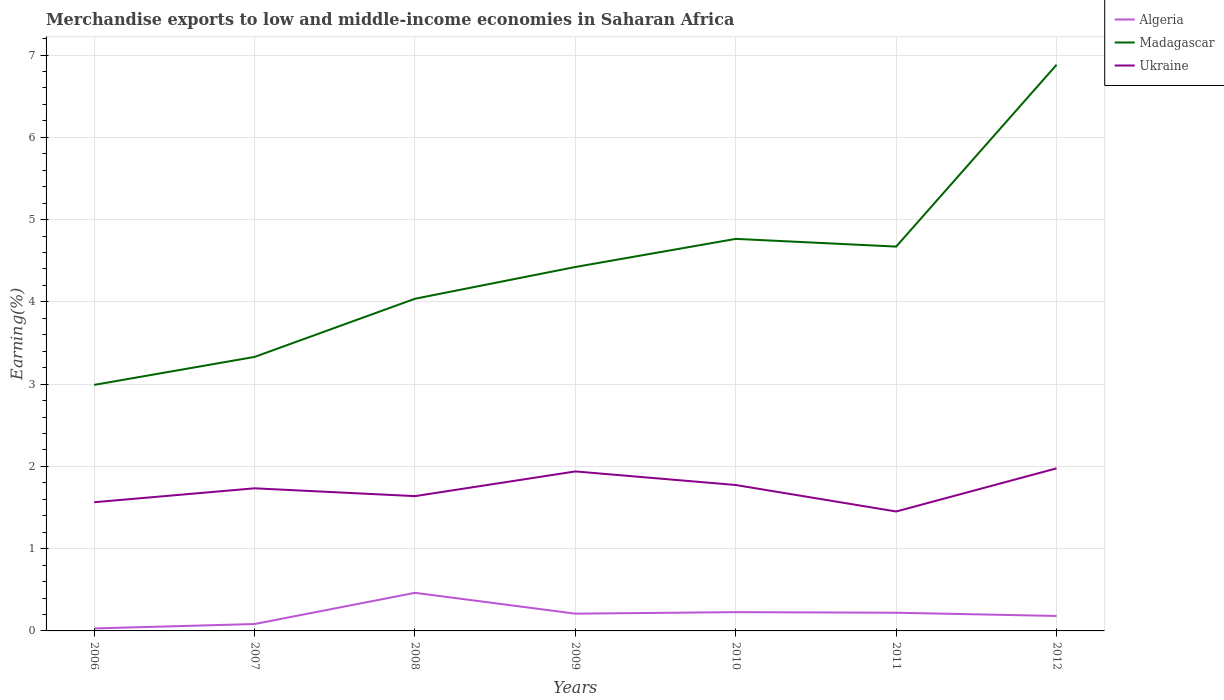Does the line corresponding to Algeria intersect with the line corresponding to Madagascar?
Provide a succinct answer. No. Is the number of lines equal to the number of legend labels?
Make the answer very short. Yes. Across all years, what is the maximum percentage of amount earned from merchandise exports in Madagascar?
Offer a very short reply. 2.99. In which year was the percentage of amount earned from merchandise exports in Madagascar maximum?
Provide a short and direct response. 2006. What is the total percentage of amount earned from merchandise exports in Ukraine in the graph?
Offer a terse response. -0.21. What is the difference between the highest and the second highest percentage of amount earned from merchandise exports in Ukraine?
Offer a terse response. 0.52. What is the difference between the highest and the lowest percentage of amount earned from merchandise exports in Ukraine?
Keep it short and to the point. 4. Is the percentage of amount earned from merchandise exports in Ukraine strictly greater than the percentage of amount earned from merchandise exports in Madagascar over the years?
Offer a very short reply. Yes. How many years are there in the graph?
Your answer should be compact. 7. Does the graph contain any zero values?
Provide a short and direct response. No. What is the title of the graph?
Keep it short and to the point. Merchandise exports to low and middle-income economies in Saharan Africa. What is the label or title of the Y-axis?
Offer a very short reply. Earning(%). What is the Earning(%) in Algeria in 2006?
Offer a terse response. 0.03. What is the Earning(%) of Madagascar in 2006?
Your answer should be very brief. 2.99. What is the Earning(%) of Ukraine in 2006?
Make the answer very short. 1.56. What is the Earning(%) in Algeria in 2007?
Provide a short and direct response. 0.08. What is the Earning(%) of Madagascar in 2007?
Your response must be concise. 3.33. What is the Earning(%) of Ukraine in 2007?
Ensure brevity in your answer.  1.73. What is the Earning(%) in Algeria in 2008?
Your answer should be very brief. 0.46. What is the Earning(%) in Madagascar in 2008?
Give a very brief answer. 4.04. What is the Earning(%) of Ukraine in 2008?
Offer a terse response. 1.64. What is the Earning(%) of Algeria in 2009?
Your answer should be very brief. 0.21. What is the Earning(%) in Madagascar in 2009?
Provide a succinct answer. 4.42. What is the Earning(%) in Ukraine in 2009?
Offer a terse response. 1.94. What is the Earning(%) in Algeria in 2010?
Provide a short and direct response. 0.23. What is the Earning(%) in Madagascar in 2010?
Provide a succinct answer. 4.77. What is the Earning(%) of Ukraine in 2010?
Ensure brevity in your answer.  1.77. What is the Earning(%) of Algeria in 2011?
Give a very brief answer. 0.22. What is the Earning(%) in Madagascar in 2011?
Offer a very short reply. 4.67. What is the Earning(%) of Ukraine in 2011?
Provide a succinct answer. 1.45. What is the Earning(%) of Algeria in 2012?
Provide a succinct answer. 0.18. What is the Earning(%) of Madagascar in 2012?
Ensure brevity in your answer.  6.88. What is the Earning(%) of Ukraine in 2012?
Make the answer very short. 1.98. Across all years, what is the maximum Earning(%) of Algeria?
Offer a terse response. 0.46. Across all years, what is the maximum Earning(%) in Madagascar?
Your answer should be very brief. 6.88. Across all years, what is the maximum Earning(%) in Ukraine?
Ensure brevity in your answer.  1.98. Across all years, what is the minimum Earning(%) in Algeria?
Your answer should be compact. 0.03. Across all years, what is the minimum Earning(%) of Madagascar?
Offer a terse response. 2.99. Across all years, what is the minimum Earning(%) in Ukraine?
Make the answer very short. 1.45. What is the total Earning(%) in Algeria in the graph?
Your answer should be very brief. 1.42. What is the total Earning(%) in Madagascar in the graph?
Give a very brief answer. 31.1. What is the total Earning(%) of Ukraine in the graph?
Make the answer very short. 12.08. What is the difference between the Earning(%) of Algeria in 2006 and that in 2007?
Provide a short and direct response. -0.05. What is the difference between the Earning(%) of Madagascar in 2006 and that in 2007?
Give a very brief answer. -0.34. What is the difference between the Earning(%) of Ukraine in 2006 and that in 2007?
Offer a terse response. -0.17. What is the difference between the Earning(%) of Algeria in 2006 and that in 2008?
Your response must be concise. -0.43. What is the difference between the Earning(%) of Madagascar in 2006 and that in 2008?
Keep it short and to the point. -1.05. What is the difference between the Earning(%) in Ukraine in 2006 and that in 2008?
Give a very brief answer. -0.07. What is the difference between the Earning(%) in Algeria in 2006 and that in 2009?
Ensure brevity in your answer.  -0.18. What is the difference between the Earning(%) of Madagascar in 2006 and that in 2009?
Provide a short and direct response. -1.43. What is the difference between the Earning(%) in Ukraine in 2006 and that in 2009?
Offer a very short reply. -0.37. What is the difference between the Earning(%) of Algeria in 2006 and that in 2010?
Provide a succinct answer. -0.2. What is the difference between the Earning(%) in Madagascar in 2006 and that in 2010?
Provide a succinct answer. -1.77. What is the difference between the Earning(%) of Ukraine in 2006 and that in 2010?
Ensure brevity in your answer.  -0.21. What is the difference between the Earning(%) in Algeria in 2006 and that in 2011?
Ensure brevity in your answer.  -0.19. What is the difference between the Earning(%) of Madagascar in 2006 and that in 2011?
Provide a succinct answer. -1.68. What is the difference between the Earning(%) of Ukraine in 2006 and that in 2011?
Provide a short and direct response. 0.11. What is the difference between the Earning(%) of Algeria in 2006 and that in 2012?
Offer a very short reply. -0.15. What is the difference between the Earning(%) in Madagascar in 2006 and that in 2012?
Your response must be concise. -3.89. What is the difference between the Earning(%) in Ukraine in 2006 and that in 2012?
Provide a short and direct response. -0.41. What is the difference between the Earning(%) of Algeria in 2007 and that in 2008?
Ensure brevity in your answer.  -0.38. What is the difference between the Earning(%) of Madagascar in 2007 and that in 2008?
Provide a short and direct response. -0.71. What is the difference between the Earning(%) in Ukraine in 2007 and that in 2008?
Provide a short and direct response. 0.1. What is the difference between the Earning(%) of Algeria in 2007 and that in 2009?
Make the answer very short. -0.13. What is the difference between the Earning(%) of Madagascar in 2007 and that in 2009?
Your answer should be very brief. -1.09. What is the difference between the Earning(%) in Ukraine in 2007 and that in 2009?
Provide a succinct answer. -0.21. What is the difference between the Earning(%) of Algeria in 2007 and that in 2010?
Give a very brief answer. -0.14. What is the difference between the Earning(%) of Madagascar in 2007 and that in 2010?
Give a very brief answer. -1.43. What is the difference between the Earning(%) of Ukraine in 2007 and that in 2010?
Give a very brief answer. -0.04. What is the difference between the Earning(%) of Algeria in 2007 and that in 2011?
Provide a succinct answer. -0.14. What is the difference between the Earning(%) in Madagascar in 2007 and that in 2011?
Your answer should be compact. -1.34. What is the difference between the Earning(%) in Ukraine in 2007 and that in 2011?
Make the answer very short. 0.28. What is the difference between the Earning(%) of Algeria in 2007 and that in 2012?
Your answer should be compact. -0.1. What is the difference between the Earning(%) of Madagascar in 2007 and that in 2012?
Ensure brevity in your answer.  -3.55. What is the difference between the Earning(%) in Ukraine in 2007 and that in 2012?
Provide a short and direct response. -0.24. What is the difference between the Earning(%) of Algeria in 2008 and that in 2009?
Your answer should be compact. 0.25. What is the difference between the Earning(%) in Madagascar in 2008 and that in 2009?
Provide a short and direct response. -0.39. What is the difference between the Earning(%) in Ukraine in 2008 and that in 2009?
Your answer should be very brief. -0.3. What is the difference between the Earning(%) in Algeria in 2008 and that in 2010?
Your answer should be compact. 0.23. What is the difference between the Earning(%) in Madagascar in 2008 and that in 2010?
Keep it short and to the point. -0.73. What is the difference between the Earning(%) in Ukraine in 2008 and that in 2010?
Provide a short and direct response. -0.14. What is the difference between the Earning(%) of Algeria in 2008 and that in 2011?
Ensure brevity in your answer.  0.24. What is the difference between the Earning(%) in Madagascar in 2008 and that in 2011?
Provide a short and direct response. -0.63. What is the difference between the Earning(%) of Ukraine in 2008 and that in 2011?
Your answer should be very brief. 0.19. What is the difference between the Earning(%) in Algeria in 2008 and that in 2012?
Give a very brief answer. 0.28. What is the difference between the Earning(%) of Madagascar in 2008 and that in 2012?
Your response must be concise. -2.84. What is the difference between the Earning(%) of Ukraine in 2008 and that in 2012?
Provide a succinct answer. -0.34. What is the difference between the Earning(%) of Algeria in 2009 and that in 2010?
Offer a very short reply. -0.02. What is the difference between the Earning(%) of Madagascar in 2009 and that in 2010?
Provide a short and direct response. -0.34. What is the difference between the Earning(%) of Ukraine in 2009 and that in 2010?
Offer a terse response. 0.17. What is the difference between the Earning(%) of Algeria in 2009 and that in 2011?
Your answer should be compact. -0.01. What is the difference between the Earning(%) of Madagascar in 2009 and that in 2011?
Provide a short and direct response. -0.25. What is the difference between the Earning(%) in Ukraine in 2009 and that in 2011?
Your response must be concise. 0.49. What is the difference between the Earning(%) of Algeria in 2009 and that in 2012?
Offer a terse response. 0.03. What is the difference between the Earning(%) in Madagascar in 2009 and that in 2012?
Provide a short and direct response. -2.46. What is the difference between the Earning(%) of Ukraine in 2009 and that in 2012?
Keep it short and to the point. -0.04. What is the difference between the Earning(%) in Algeria in 2010 and that in 2011?
Keep it short and to the point. 0.01. What is the difference between the Earning(%) in Madagascar in 2010 and that in 2011?
Provide a short and direct response. 0.09. What is the difference between the Earning(%) in Ukraine in 2010 and that in 2011?
Offer a very short reply. 0.32. What is the difference between the Earning(%) of Algeria in 2010 and that in 2012?
Your answer should be compact. 0.05. What is the difference between the Earning(%) in Madagascar in 2010 and that in 2012?
Your answer should be very brief. -2.12. What is the difference between the Earning(%) in Ukraine in 2010 and that in 2012?
Your answer should be compact. -0.2. What is the difference between the Earning(%) of Algeria in 2011 and that in 2012?
Keep it short and to the point. 0.04. What is the difference between the Earning(%) in Madagascar in 2011 and that in 2012?
Your response must be concise. -2.21. What is the difference between the Earning(%) in Ukraine in 2011 and that in 2012?
Provide a succinct answer. -0.52. What is the difference between the Earning(%) in Algeria in 2006 and the Earning(%) in Madagascar in 2007?
Give a very brief answer. -3.3. What is the difference between the Earning(%) in Algeria in 2006 and the Earning(%) in Ukraine in 2007?
Your response must be concise. -1.7. What is the difference between the Earning(%) of Madagascar in 2006 and the Earning(%) of Ukraine in 2007?
Offer a very short reply. 1.26. What is the difference between the Earning(%) in Algeria in 2006 and the Earning(%) in Madagascar in 2008?
Keep it short and to the point. -4.01. What is the difference between the Earning(%) of Algeria in 2006 and the Earning(%) of Ukraine in 2008?
Your response must be concise. -1.61. What is the difference between the Earning(%) of Madagascar in 2006 and the Earning(%) of Ukraine in 2008?
Offer a very short reply. 1.35. What is the difference between the Earning(%) of Algeria in 2006 and the Earning(%) of Madagascar in 2009?
Your answer should be compact. -4.39. What is the difference between the Earning(%) of Algeria in 2006 and the Earning(%) of Ukraine in 2009?
Provide a short and direct response. -1.91. What is the difference between the Earning(%) in Madagascar in 2006 and the Earning(%) in Ukraine in 2009?
Provide a succinct answer. 1.05. What is the difference between the Earning(%) of Algeria in 2006 and the Earning(%) of Madagascar in 2010?
Ensure brevity in your answer.  -4.74. What is the difference between the Earning(%) in Algeria in 2006 and the Earning(%) in Ukraine in 2010?
Your answer should be very brief. -1.74. What is the difference between the Earning(%) of Madagascar in 2006 and the Earning(%) of Ukraine in 2010?
Ensure brevity in your answer.  1.22. What is the difference between the Earning(%) in Algeria in 2006 and the Earning(%) in Madagascar in 2011?
Keep it short and to the point. -4.64. What is the difference between the Earning(%) in Algeria in 2006 and the Earning(%) in Ukraine in 2011?
Your response must be concise. -1.42. What is the difference between the Earning(%) in Madagascar in 2006 and the Earning(%) in Ukraine in 2011?
Offer a very short reply. 1.54. What is the difference between the Earning(%) of Algeria in 2006 and the Earning(%) of Madagascar in 2012?
Keep it short and to the point. -6.85. What is the difference between the Earning(%) of Algeria in 2006 and the Earning(%) of Ukraine in 2012?
Keep it short and to the point. -1.95. What is the difference between the Earning(%) of Madagascar in 2006 and the Earning(%) of Ukraine in 2012?
Your response must be concise. 1.01. What is the difference between the Earning(%) in Algeria in 2007 and the Earning(%) in Madagascar in 2008?
Give a very brief answer. -3.95. What is the difference between the Earning(%) in Algeria in 2007 and the Earning(%) in Ukraine in 2008?
Offer a very short reply. -1.55. What is the difference between the Earning(%) in Madagascar in 2007 and the Earning(%) in Ukraine in 2008?
Your answer should be compact. 1.69. What is the difference between the Earning(%) of Algeria in 2007 and the Earning(%) of Madagascar in 2009?
Keep it short and to the point. -4.34. What is the difference between the Earning(%) of Algeria in 2007 and the Earning(%) of Ukraine in 2009?
Keep it short and to the point. -1.85. What is the difference between the Earning(%) in Madagascar in 2007 and the Earning(%) in Ukraine in 2009?
Offer a terse response. 1.39. What is the difference between the Earning(%) in Algeria in 2007 and the Earning(%) in Madagascar in 2010?
Your answer should be compact. -4.68. What is the difference between the Earning(%) in Algeria in 2007 and the Earning(%) in Ukraine in 2010?
Your response must be concise. -1.69. What is the difference between the Earning(%) in Madagascar in 2007 and the Earning(%) in Ukraine in 2010?
Offer a terse response. 1.56. What is the difference between the Earning(%) of Algeria in 2007 and the Earning(%) of Madagascar in 2011?
Give a very brief answer. -4.59. What is the difference between the Earning(%) in Algeria in 2007 and the Earning(%) in Ukraine in 2011?
Your response must be concise. -1.37. What is the difference between the Earning(%) in Madagascar in 2007 and the Earning(%) in Ukraine in 2011?
Your response must be concise. 1.88. What is the difference between the Earning(%) of Algeria in 2007 and the Earning(%) of Madagascar in 2012?
Offer a terse response. -6.8. What is the difference between the Earning(%) in Algeria in 2007 and the Earning(%) in Ukraine in 2012?
Provide a short and direct response. -1.89. What is the difference between the Earning(%) in Madagascar in 2007 and the Earning(%) in Ukraine in 2012?
Offer a very short reply. 1.35. What is the difference between the Earning(%) of Algeria in 2008 and the Earning(%) of Madagascar in 2009?
Ensure brevity in your answer.  -3.96. What is the difference between the Earning(%) of Algeria in 2008 and the Earning(%) of Ukraine in 2009?
Your answer should be compact. -1.48. What is the difference between the Earning(%) of Madagascar in 2008 and the Earning(%) of Ukraine in 2009?
Your response must be concise. 2.1. What is the difference between the Earning(%) of Algeria in 2008 and the Earning(%) of Madagascar in 2010?
Provide a succinct answer. -4.3. What is the difference between the Earning(%) of Algeria in 2008 and the Earning(%) of Ukraine in 2010?
Provide a short and direct response. -1.31. What is the difference between the Earning(%) in Madagascar in 2008 and the Earning(%) in Ukraine in 2010?
Provide a short and direct response. 2.26. What is the difference between the Earning(%) in Algeria in 2008 and the Earning(%) in Madagascar in 2011?
Ensure brevity in your answer.  -4.21. What is the difference between the Earning(%) of Algeria in 2008 and the Earning(%) of Ukraine in 2011?
Ensure brevity in your answer.  -0.99. What is the difference between the Earning(%) in Madagascar in 2008 and the Earning(%) in Ukraine in 2011?
Offer a terse response. 2.59. What is the difference between the Earning(%) in Algeria in 2008 and the Earning(%) in Madagascar in 2012?
Your response must be concise. -6.42. What is the difference between the Earning(%) of Algeria in 2008 and the Earning(%) of Ukraine in 2012?
Offer a terse response. -1.51. What is the difference between the Earning(%) of Madagascar in 2008 and the Earning(%) of Ukraine in 2012?
Offer a very short reply. 2.06. What is the difference between the Earning(%) in Algeria in 2009 and the Earning(%) in Madagascar in 2010?
Your response must be concise. -4.56. What is the difference between the Earning(%) in Algeria in 2009 and the Earning(%) in Ukraine in 2010?
Provide a short and direct response. -1.56. What is the difference between the Earning(%) in Madagascar in 2009 and the Earning(%) in Ukraine in 2010?
Keep it short and to the point. 2.65. What is the difference between the Earning(%) in Algeria in 2009 and the Earning(%) in Madagascar in 2011?
Provide a short and direct response. -4.46. What is the difference between the Earning(%) of Algeria in 2009 and the Earning(%) of Ukraine in 2011?
Provide a succinct answer. -1.24. What is the difference between the Earning(%) in Madagascar in 2009 and the Earning(%) in Ukraine in 2011?
Make the answer very short. 2.97. What is the difference between the Earning(%) in Algeria in 2009 and the Earning(%) in Madagascar in 2012?
Make the answer very short. -6.67. What is the difference between the Earning(%) in Algeria in 2009 and the Earning(%) in Ukraine in 2012?
Offer a terse response. -1.77. What is the difference between the Earning(%) of Madagascar in 2009 and the Earning(%) of Ukraine in 2012?
Ensure brevity in your answer.  2.45. What is the difference between the Earning(%) in Algeria in 2010 and the Earning(%) in Madagascar in 2011?
Your response must be concise. -4.44. What is the difference between the Earning(%) of Algeria in 2010 and the Earning(%) of Ukraine in 2011?
Offer a very short reply. -1.22. What is the difference between the Earning(%) in Madagascar in 2010 and the Earning(%) in Ukraine in 2011?
Make the answer very short. 3.31. What is the difference between the Earning(%) in Algeria in 2010 and the Earning(%) in Madagascar in 2012?
Make the answer very short. -6.65. What is the difference between the Earning(%) of Algeria in 2010 and the Earning(%) of Ukraine in 2012?
Offer a very short reply. -1.75. What is the difference between the Earning(%) in Madagascar in 2010 and the Earning(%) in Ukraine in 2012?
Your answer should be compact. 2.79. What is the difference between the Earning(%) of Algeria in 2011 and the Earning(%) of Madagascar in 2012?
Your answer should be compact. -6.66. What is the difference between the Earning(%) in Algeria in 2011 and the Earning(%) in Ukraine in 2012?
Offer a very short reply. -1.76. What is the difference between the Earning(%) in Madagascar in 2011 and the Earning(%) in Ukraine in 2012?
Give a very brief answer. 2.7. What is the average Earning(%) in Algeria per year?
Provide a succinct answer. 0.2. What is the average Earning(%) in Madagascar per year?
Offer a terse response. 4.44. What is the average Earning(%) in Ukraine per year?
Your answer should be compact. 1.73. In the year 2006, what is the difference between the Earning(%) of Algeria and Earning(%) of Madagascar?
Give a very brief answer. -2.96. In the year 2006, what is the difference between the Earning(%) of Algeria and Earning(%) of Ukraine?
Offer a very short reply. -1.53. In the year 2006, what is the difference between the Earning(%) of Madagascar and Earning(%) of Ukraine?
Your answer should be very brief. 1.43. In the year 2007, what is the difference between the Earning(%) of Algeria and Earning(%) of Madagascar?
Ensure brevity in your answer.  -3.25. In the year 2007, what is the difference between the Earning(%) of Algeria and Earning(%) of Ukraine?
Ensure brevity in your answer.  -1.65. In the year 2007, what is the difference between the Earning(%) of Madagascar and Earning(%) of Ukraine?
Provide a succinct answer. 1.6. In the year 2008, what is the difference between the Earning(%) in Algeria and Earning(%) in Madagascar?
Your answer should be compact. -3.57. In the year 2008, what is the difference between the Earning(%) of Algeria and Earning(%) of Ukraine?
Ensure brevity in your answer.  -1.18. In the year 2008, what is the difference between the Earning(%) in Madagascar and Earning(%) in Ukraine?
Offer a very short reply. 2.4. In the year 2009, what is the difference between the Earning(%) of Algeria and Earning(%) of Madagascar?
Your answer should be very brief. -4.21. In the year 2009, what is the difference between the Earning(%) of Algeria and Earning(%) of Ukraine?
Your response must be concise. -1.73. In the year 2009, what is the difference between the Earning(%) in Madagascar and Earning(%) in Ukraine?
Give a very brief answer. 2.48. In the year 2010, what is the difference between the Earning(%) in Algeria and Earning(%) in Madagascar?
Offer a terse response. -4.54. In the year 2010, what is the difference between the Earning(%) of Algeria and Earning(%) of Ukraine?
Provide a short and direct response. -1.55. In the year 2010, what is the difference between the Earning(%) in Madagascar and Earning(%) in Ukraine?
Your answer should be very brief. 2.99. In the year 2011, what is the difference between the Earning(%) of Algeria and Earning(%) of Madagascar?
Make the answer very short. -4.45. In the year 2011, what is the difference between the Earning(%) in Algeria and Earning(%) in Ukraine?
Your response must be concise. -1.23. In the year 2011, what is the difference between the Earning(%) in Madagascar and Earning(%) in Ukraine?
Keep it short and to the point. 3.22. In the year 2012, what is the difference between the Earning(%) in Algeria and Earning(%) in Madagascar?
Offer a terse response. -6.7. In the year 2012, what is the difference between the Earning(%) in Algeria and Earning(%) in Ukraine?
Make the answer very short. -1.79. In the year 2012, what is the difference between the Earning(%) of Madagascar and Earning(%) of Ukraine?
Provide a succinct answer. 4.91. What is the ratio of the Earning(%) in Algeria in 2006 to that in 2007?
Give a very brief answer. 0.36. What is the ratio of the Earning(%) of Madagascar in 2006 to that in 2007?
Give a very brief answer. 0.9. What is the ratio of the Earning(%) of Ukraine in 2006 to that in 2007?
Make the answer very short. 0.9. What is the ratio of the Earning(%) in Algeria in 2006 to that in 2008?
Ensure brevity in your answer.  0.07. What is the ratio of the Earning(%) in Madagascar in 2006 to that in 2008?
Give a very brief answer. 0.74. What is the ratio of the Earning(%) of Ukraine in 2006 to that in 2008?
Keep it short and to the point. 0.95. What is the ratio of the Earning(%) in Algeria in 2006 to that in 2009?
Ensure brevity in your answer.  0.14. What is the ratio of the Earning(%) of Madagascar in 2006 to that in 2009?
Offer a very short reply. 0.68. What is the ratio of the Earning(%) in Ukraine in 2006 to that in 2009?
Provide a short and direct response. 0.81. What is the ratio of the Earning(%) of Algeria in 2006 to that in 2010?
Provide a short and direct response. 0.13. What is the ratio of the Earning(%) of Madagascar in 2006 to that in 2010?
Make the answer very short. 0.63. What is the ratio of the Earning(%) in Ukraine in 2006 to that in 2010?
Give a very brief answer. 0.88. What is the ratio of the Earning(%) of Algeria in 2006 to that in 2011?
Ensure brevity in your answer.  0.14. What is the ratio of the Earning(%) in Madagascar in 2006 to that in 2011?
Your response must be concise. 0.64. What is the ratio of the Earning(%) of Ukraine in 2006 to that in 2011?
Offer a terse response. 1.08. What is the ratio of the Earning(%) in Algeria in 2006 to that in 2012?
Offer a very short reply. 0.17. What is the ratio of the Earning(%) of Madagascar in 2006 to that in 2012?
Your answer should be compact. 0.43. What is the ratio of the Earning(%) in Ukraine in 2006 to that in 2012?
Give a very brief answer. 0.79. What is the ratio of the Earning(%) in Algeria in 2007 to that in 2008?
Your answer should be very brief. 0.18. What is the ratio of the Earning(%) of Madagascar in 2007 to that in 2008?
Offer a terse response. 0.82. What is the ratio of the Earning(%) of Ukraine in 2007 to that in 2008?
Provide a short and direct response. 1.06. What is the ratio of the Earning(%) of Algeria in 2007 to that in 2009?
Provide a short and direct response. 0.4. What is the ratio of the Earning(%) of Madagascar in 2007 to that in 2009?
Your answer should be very brief. 0.75. What is the ratio of the Earning(%) in Ukraine in 2007 to that in 2009?
Your response must be concise. 0.89. What is the ratio of the Earning(%) of Algeria in 2007 to that in 2010?
Make the answer very short. 0.37. What is the ratio of the Earning(%) in Madagascar in 2007 to that in 2010?
Your answer should be compact. 0.7. What is the ratio of the Earning(%) in Ukraine in 2007 to that in 2010?
Offer a terse response. 0.98. What is the ratio of the Earning(%) in Algeria in 2007 to that in 2011?
Make the answer very short. 0.38. What is the ratio of the Earning(%) of Madagascar in 2007 to that in 2011?
Keep it short and to the point. 0.71. What is the ratio of the Earning(%) of Ukraine in 2007 to that in 2011?
Your answer should be very brief. 1.19. What is the ratio of the Earning(%) of Algeria in 2007 to that in 2012?
Your answer should be very brief. 0.46. What is the ratio of the Earning(%) of Madagascar in 2007 to that in 2012?
Give a very brief answer. 0.48. What is the ratio of the Earning(%) of Ukraine in 2007 to that in 2012?
Make the answer very short. 0.88. What is the ratio of the Earning(%) in Algeria in 2008 to that in 2009?
Ensure brevity in your answer.  2.21. What is the ratio of the Earning(%) in Madagascar in 2008 to that in 2009?
Provide a succinct answer. 0.91. What is the ratio of the Earning(%) in Ukraine in 2008 to that in 2009?
Your response must be concise. 0.85. What is the ratio of the Earning(%) in Algeria in 2008 to that in 2010?
Your answer should be very brief. 2.03. What is the ratio of the Earning(%) of Madagascar in 2008 to that in 2010?
Your answer should be very brief. 0.85. What is the ratio of the Earning(%) in Ukraine in 2008 to that in 2010?
Offer a terse response. 0.92. What is the ratio of the Earning(%) in Algeria in 2008 to that in 2011?
Provide a short and direct response. 2.09. What is the ratio of the Earning(%) in Madagascar in 2008 to that in 2011?
Your response must be concise. 0.86. What is the ratio of the Earning(%) in Ukraine in 2008 to that in 2011?
Make the answer very short. 1.13. What is the ratio of the Earning(%) of Algeria in 2008 to that in 2012?
Keep it short and to the point. 2.55. What is the ratio of the Earning(%) in Madagascar in 2008 to that in 2012?
Ensure brevity in your answer.  0.59. What is the ratio of the Earning(%) of Ukraine in 2008 to that in 2012?
Your answer should be very brief. 0.83. What is the ratio of the Earning(%) of Algeria in 2009 to that in 2010?
Your response must be concise. 0.92. What is the ratio of the Earning(%) of Madagascar in 2009 to that in 2010?
Provide a succinct answer. 0.93. What is the ratio of the Earning(%) in Ukraine in 2009 to that in 2010?
Your response must be concise. 1.09. What is the ratio of the Earning(%) in Algeria in 2009 to that in 2011?
Make the answer very short. 0.95. What is the ratio of the Earning(%) in Madagascar in 2009 to that in 2011?
Provide a short and direct response. 0.95. What is the ratio of the Earning(%) of Ukraine in 2009 to that in 2011?
Your answer should be compact. 1.34. What is the ratio of the Earning(%) of Algeria in 2009 to that in 2012?
Your answer should be compact. 1.15. What is the ratio of the Earning(%) in Madagascar in 2009 to that in 2012?
Your answer should be compact. 0.64. What is the ratio of the Earning(%) of Ukraine in 2009 to that in 2012?
Give a very brief answer. 0.98. What is the ratio of the Earning(%) in Algeria in 2010 to that in 2011?
Give a very brief answer. 1.03. What is the ratio of the Earning(%) in Madagascar in 2010 to that in 2011?
Keep it short and to the point. 1.02. What is the ratio of the Earning(%) of Ukraine in 2010 to that in 2011?
Your answer should be very brief. 1.22. What is the ratio of the Earning(%) of Algeria in 2010 to that in 2012?
Offer a terse response. 1.26. What is the ratio of the Earning(%) of Madagascar in 2010 to that in 2012?
Offer a very short reply. 0.69. What is the ratio of the Earning(%) of Ukraine in 2010 to that in 2012?
Provide a short and direct response. 0.9. What is the ratio of the Earning(%) of Algeria in 2011 to that in 2012?
Keep it short and to the point. 1.22. What is the ratio of the Earning(%) of Madagascar in 2011 to that in 2012?
Your response must be concise. 0.68. What is the ratio of the Earning(%) in Ukraine in 2011 to that in 2012?
Your answer should be compact. 0.73. What is the difference between the highest and the second highest Earning(%) in Algeria?
Make the answer very short. 0.23. What is the difference between the highest and the second highest Earning(%) of Madagascar?
Make the answer very short. 2.12. What is the difference between the highest and the second highest Earning(%) of Ukraine?
Ensure brevity in your answer.  0.04. What is the difference between the highest and the lowest Earning(%) of Algeria?
Provide a short and direct response. 0.43. What is the difference between the highest and the lowest Earning(%) in Madagascar?
Offer a very short reply. 3.89. What is the difference between the highest and the lowest Earning(%) of Ukraine?
Your answer should be compact. 0.52. 